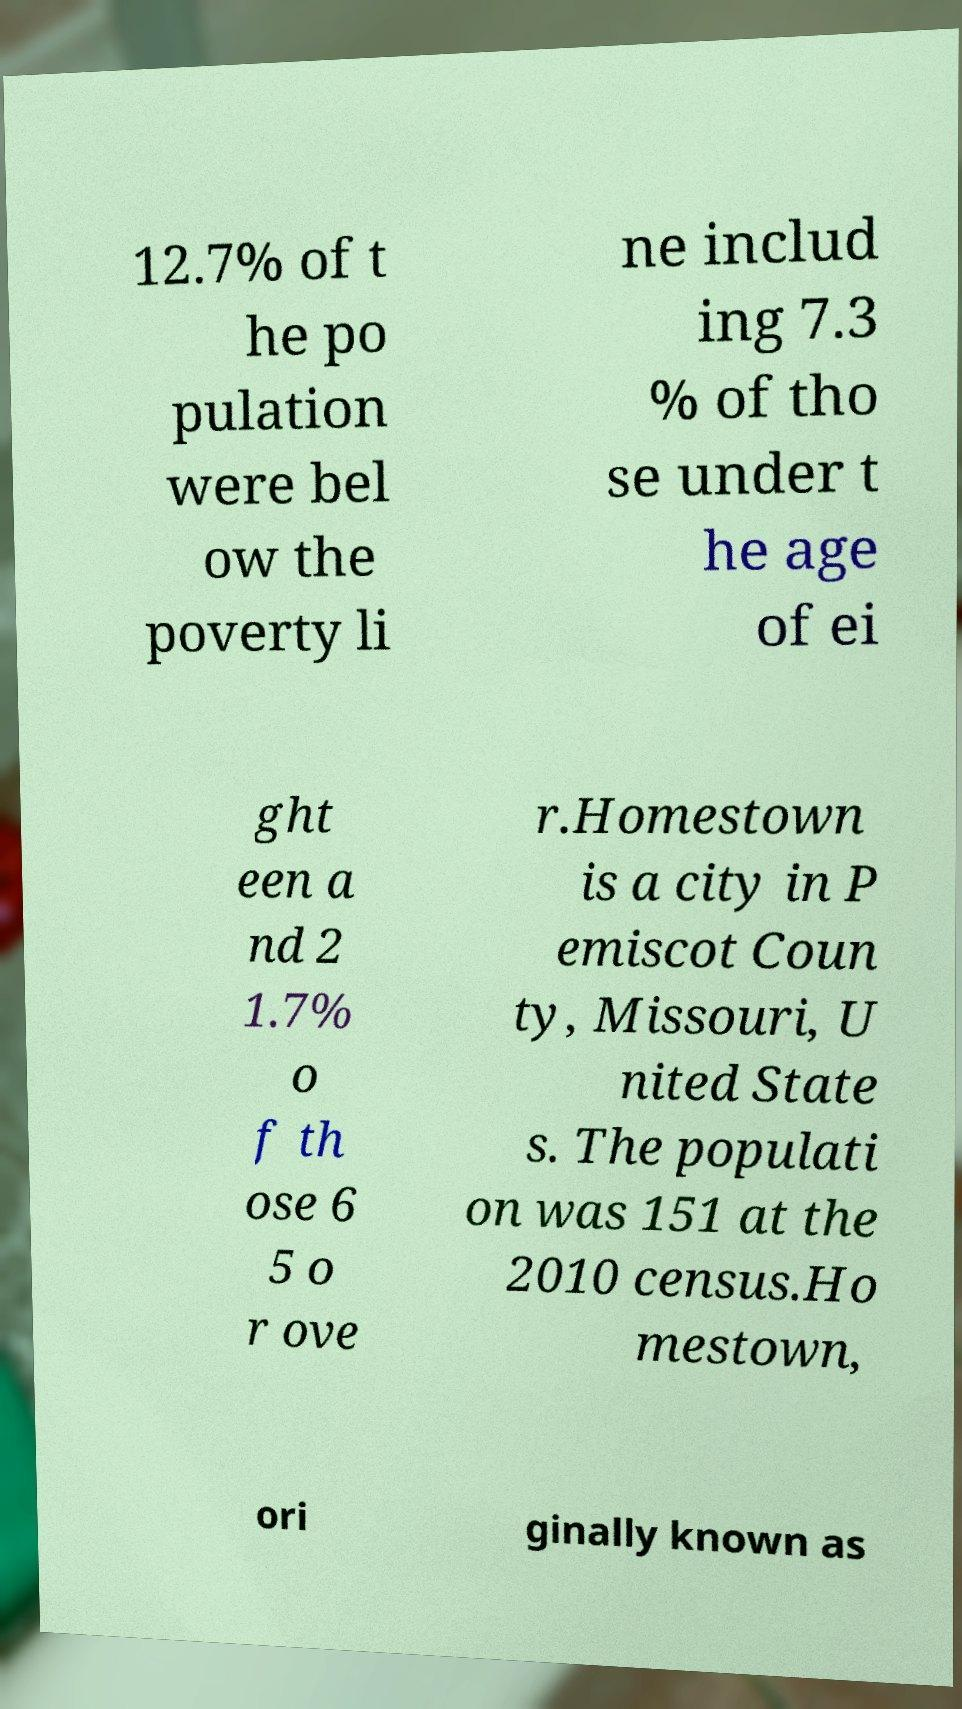Please read and relay the text visible in this image. What does it say? 12.7% of t he po pulation were bel ow the poverty li ne includ ing 7.3 % of tho se under t he age of ei ght een a nd 2 1.7% o f th ose 6 5 o r ove r.Homestown is a city in P emiscot Coun ty, Missouri, U nited State s. The populati on was 151 at the 2010 census.Ho mestown, ori ginally known as 